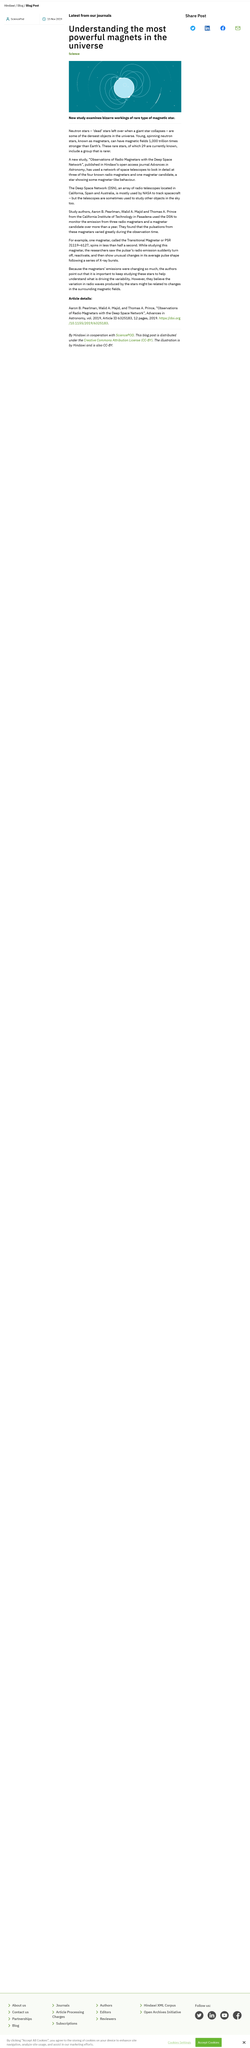Give some essential details in this illustration. DSN stands for Deep Space Network, a system of communication facilities that facilitates scientific research and exploration in outer space. The article discusses the topic of magnetic stars, which are stars that have a strong magnetic field. The DSN is located in California, Spain, and Australia. 